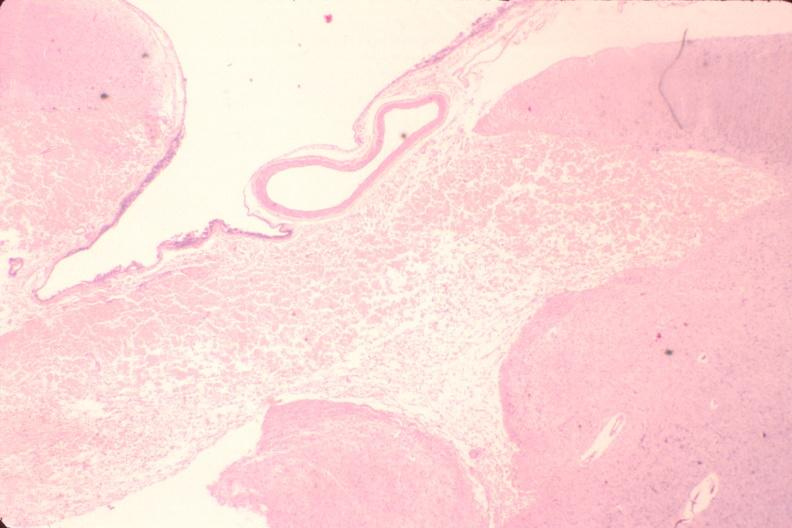where is this?
Answer the question using a single word or phrase. Nervous 